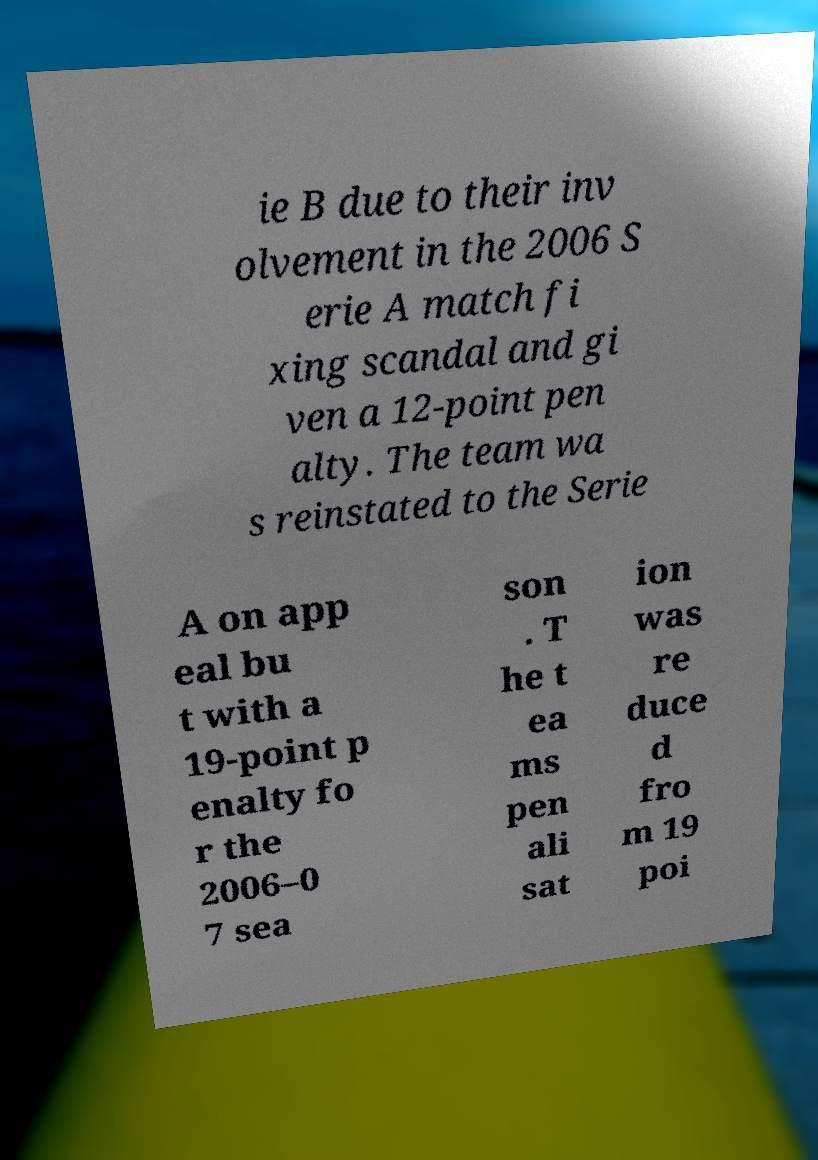What messages or text are displayed in this image? I need them in a readable, typed format. ie B due to their inv olvement in the 2006 S erie A match fi xing scandal and gi ven a 12-point pen alty. The team wa s reinstated to the Serie A on app eal bu t with a 19-point p enalty fo r the 2006–0 7 sea son . T he t ea ms pen ali sat ion was re duce d fro m 19 poi 